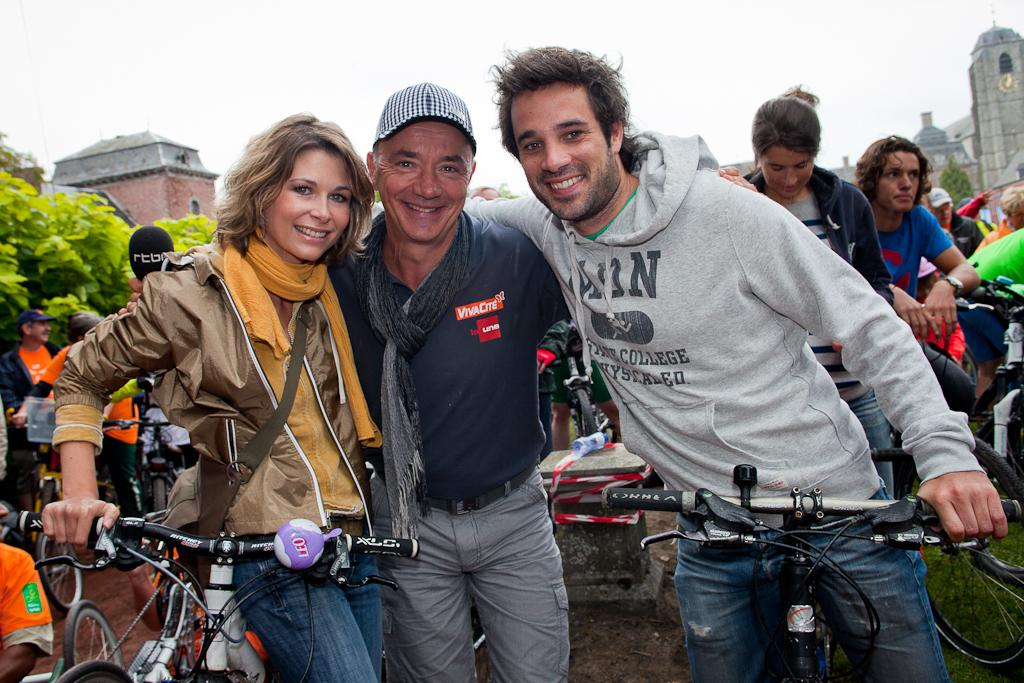What is happening in the image involving a group of people? There is a group of people in the image, and they are standing and holding a bicycle. How are the people in the image feeling or expressing themselves? The people in the image are smiling. What can be seen in the background of the image? There are trees and a building visible in the background of the image. What type of cracker is being used as a prop in the image? There is no cracker present in the image. What level of education is being taught in the image? There is no educational activity depicted in the image. 